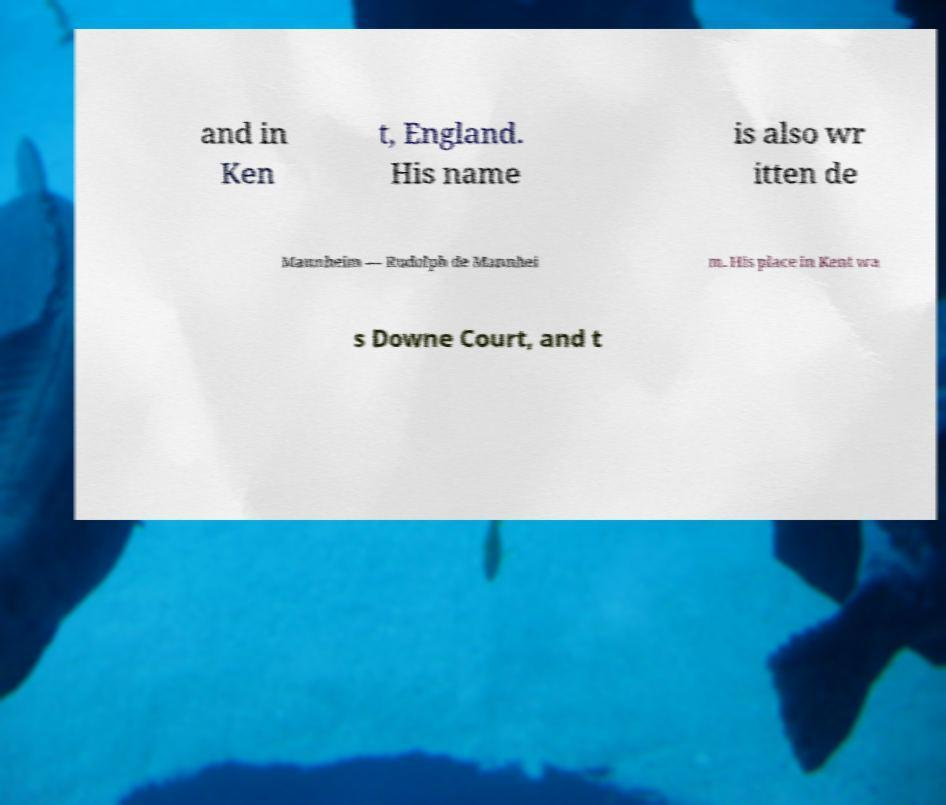Could you extract and type out the text from this image? and in Ken t, England. His name is also wr itten de Mannheim — Rudolph de Mannhei m. His place in Kent wa s Downe Court, and t 